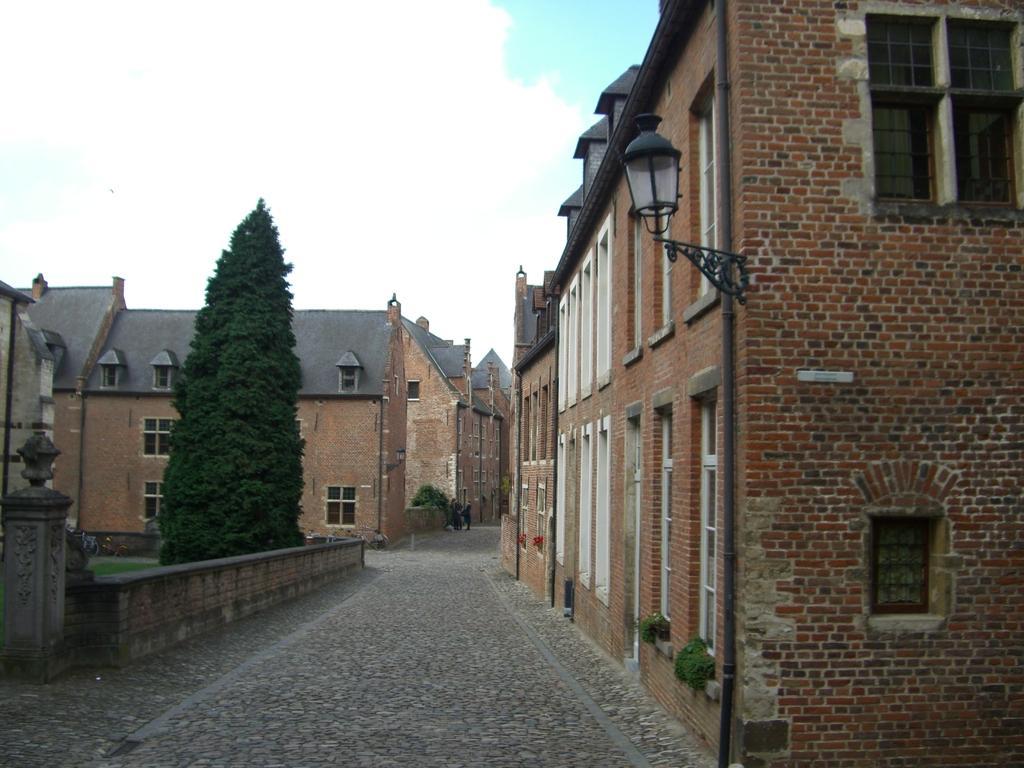Can you describe this image briefly? On the left side, there is a tree. Beside this tree, there is a wall. Beside this wall, there is a road. On the right side, there is a building which is having windows and a light attached to the wall. In the background, there are buildings which are having windows and roofs and there are clouds in the sky. 